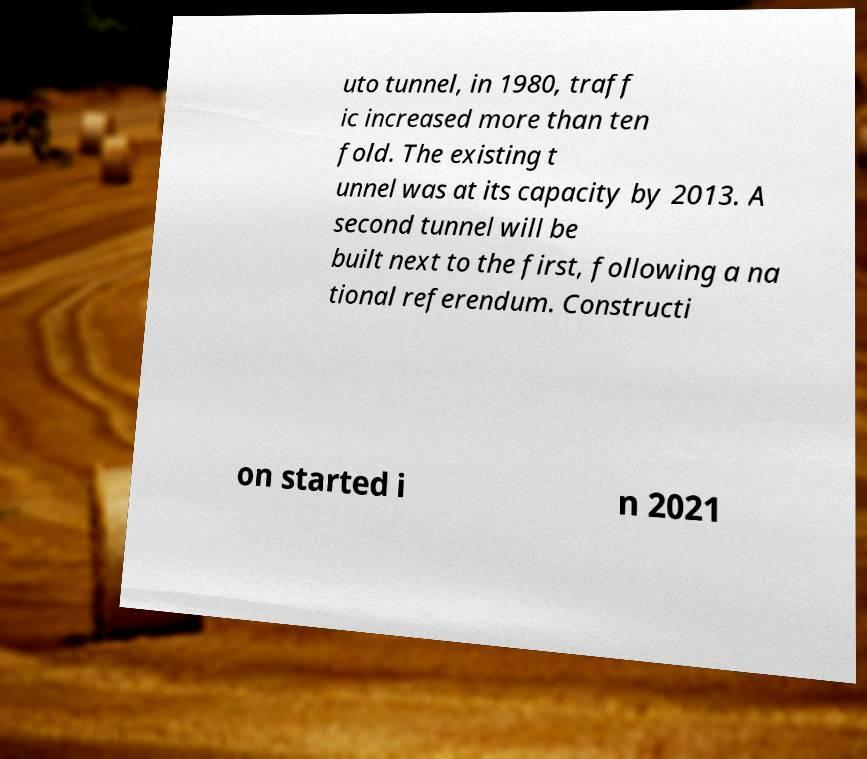I need the written content from this picture converted into text. Can you do that? uto tunnel, in 1980, traff ic increased more than ten fold. The existing t unnel was at its capacity by 2013. A second tunnel will be built next to the first, following a na tional referendum. Constructi on started i n 2021 